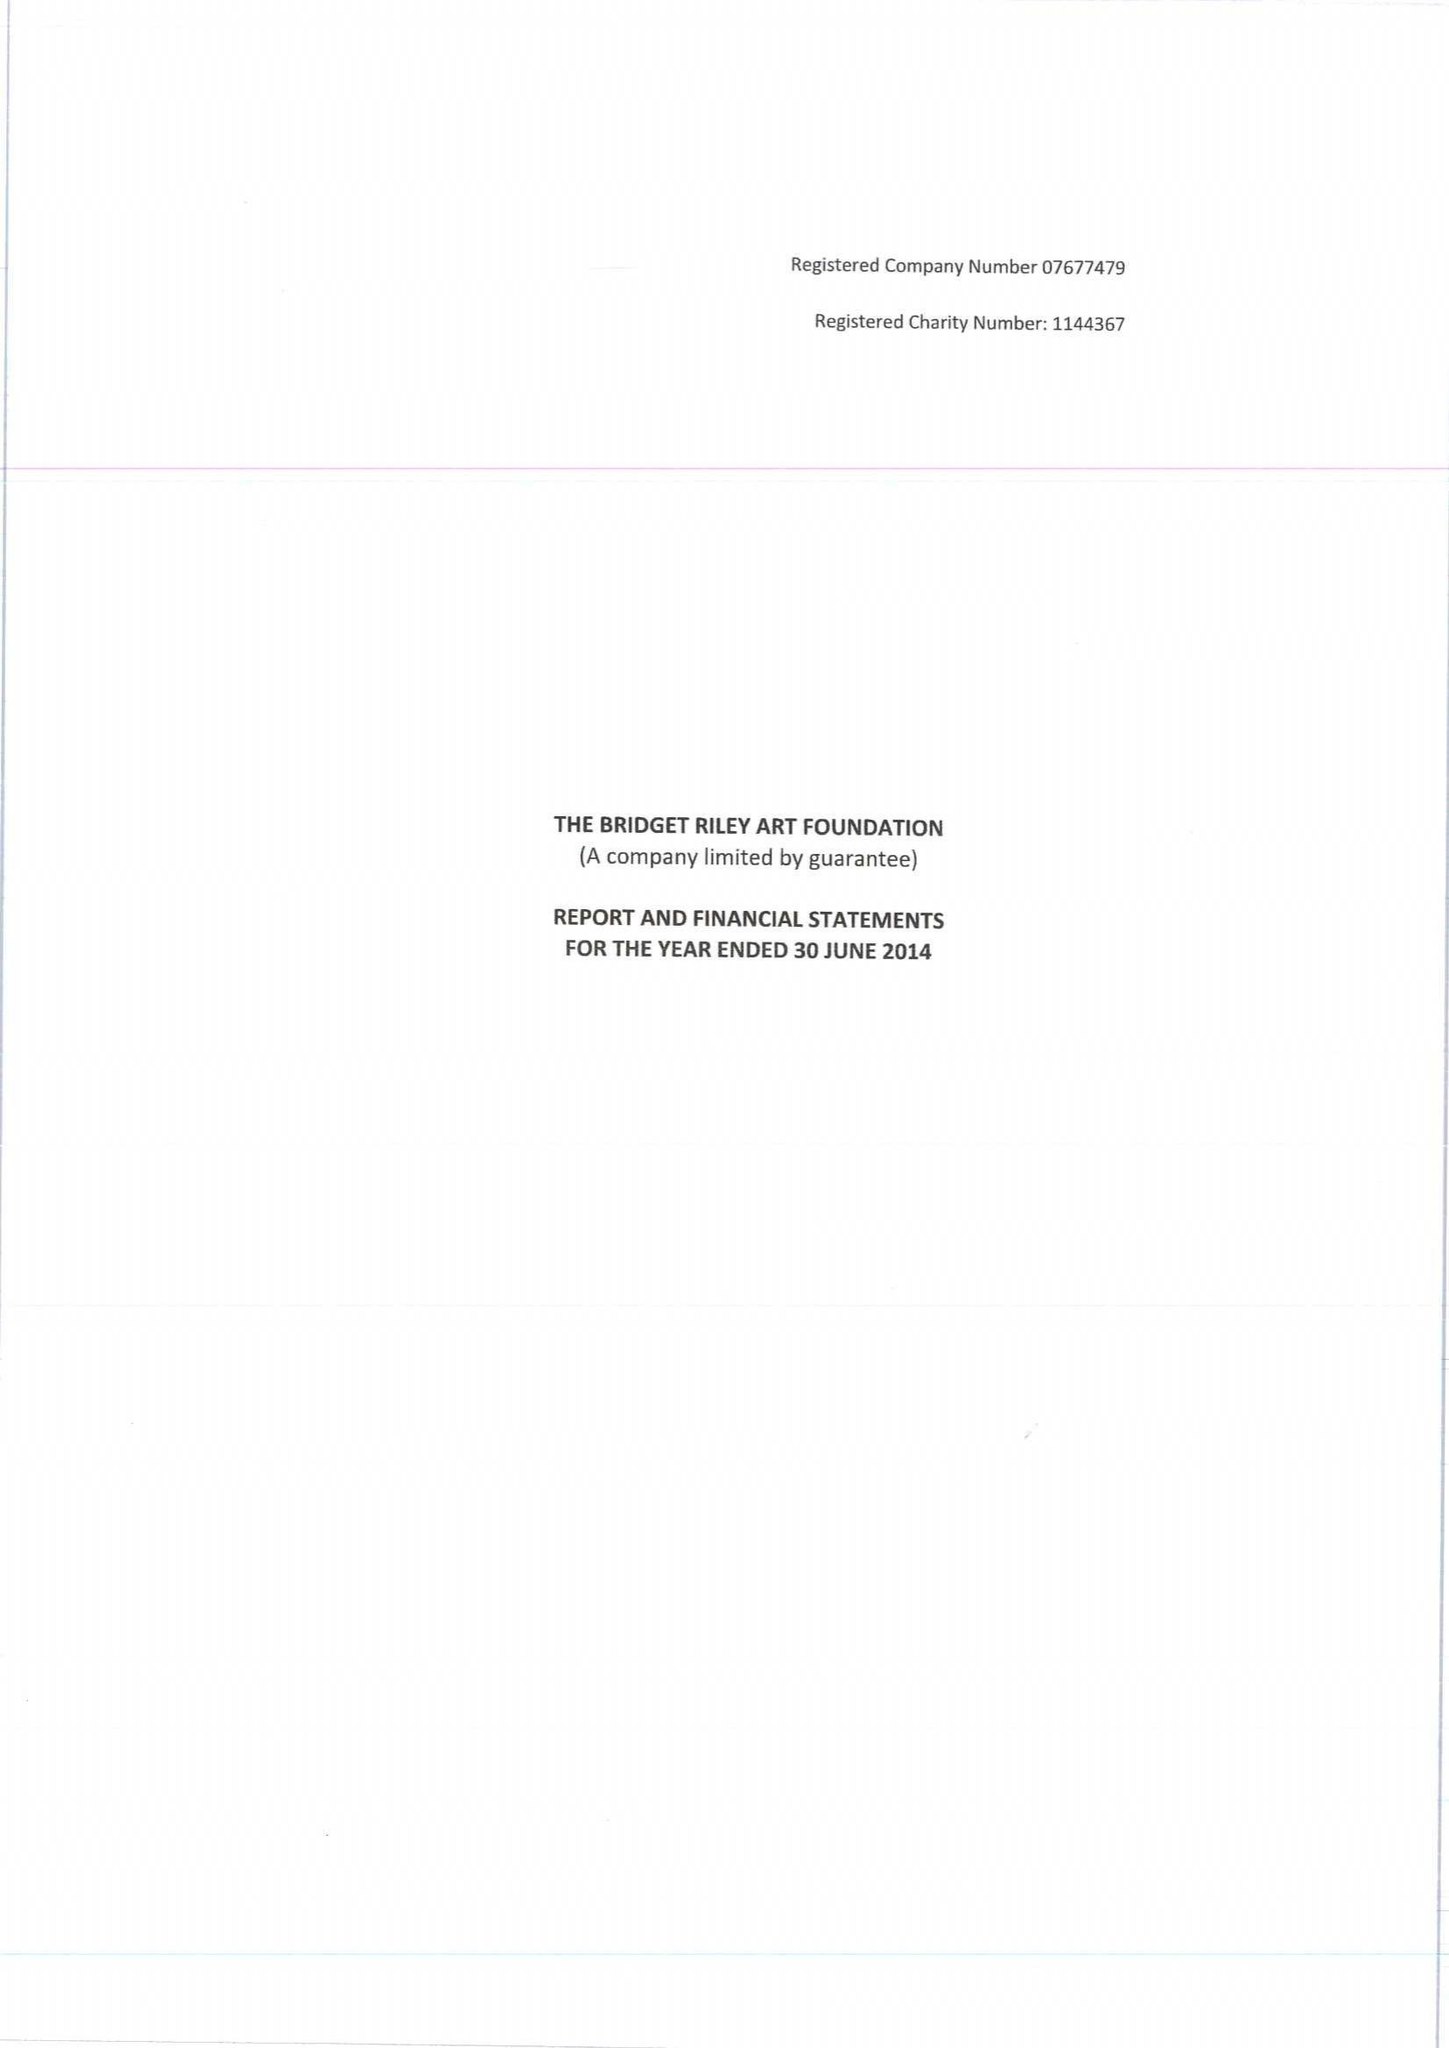What is the value for the charity_number?
Answer the question using a single word or phrase. 1144367 